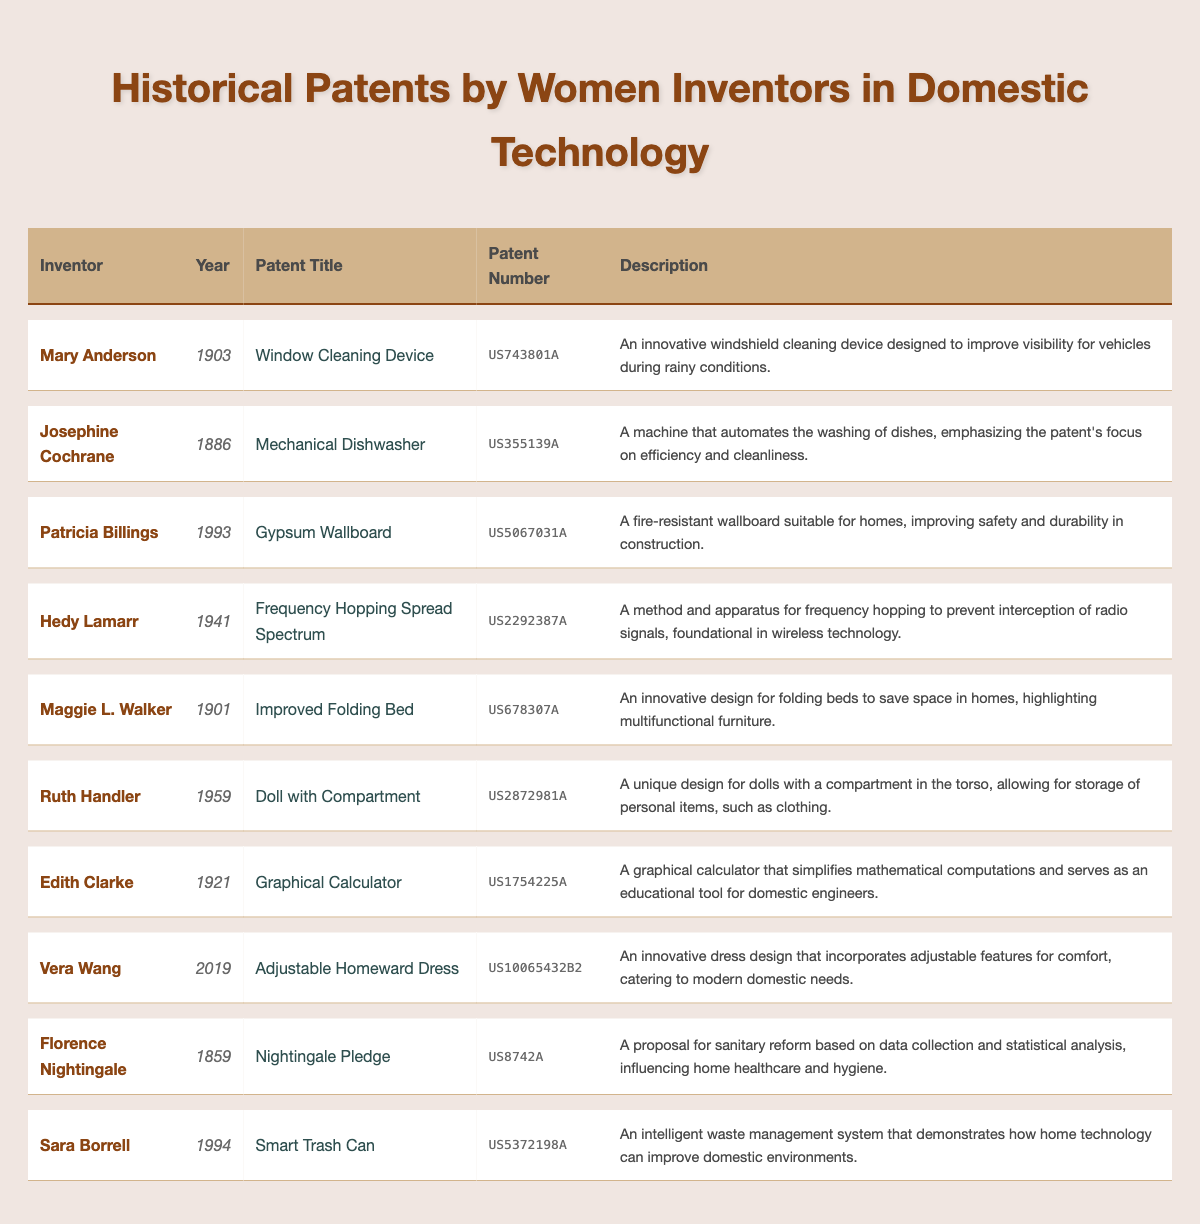What year was the Mechanical Dishwasher patented? The table lists "Josephine Cochrane" as the inventor of the Mechanical Dishwasher, and it shows the year as 1886.
Answer: 1886 Who is the inventor of the Adjustable Homeward Dress? The table indicates that "Vera Wang" is the inventor of the Adjustable Homeward Dress.
Answer: Vera Wang What is the patent number for the Improved Folding Bed? The table provides the patent number for the Improved Folding Bed as "US678307A".
Answer: US678307A How many inventions were patented in the 1900s? There are four patents listed in the years 1901, 1903, 1921, and 1941 from the data, which total four inventions after finding patents only in that century.
Answer: 4 Which invention was patented first, the Window Cleaning Device or the Mechanical Dishwasher? The Mechanical Dishwasher patented in 1886 precedes the Window Cleaning Device which was patented in 1903.
Answer: Mechanical Dishwasher Did any of the patents focus on healthcare or hygiene? Yes, the Nightingale Pledge, patented in 1859, is related to sanitary reform and healthcare.
Answer: Yes How many patents were granted to women inventors after 1990? The table shows three patents granted after 1990: Gypsum Wallboard (1993), Smart Trash Can (1994), and Adjustable Homeward Dress (2019), totaling three.
Answer: 3 What was the main focus of the invention by Hedy Lamarr? Hedy Lamarr's invention, Frequency Hopping Spread Spectrum, focuses on preventing the interception of radio signals.
Answer: Preventing radio signal interception Which two patents were designed to improve home safety and durability? The Gypsum Wallboard and the Nightingale Pledge both aim to improve safety and durability in home environments.
Answer: Gypsum Wallboard and Nightingale Pledge What is the significance of the Graphical Calculator patented by Edith Clarke? The Graphical Calculator simplifies mathematical computations and serves as an educational tool for domestic engineers, highlighting its significance in education and engineering.
Answer: Educational tool for domestic engineers Which inventor has patents in the 1940s and what was the invention? The table identifies Hedy Lamarr as the inventor with a patent in 1941 for the Frequency Hopping Spread Spectrum.
Answer: Hedy Lamarr, Frequency Hopping Spread Spectrum 